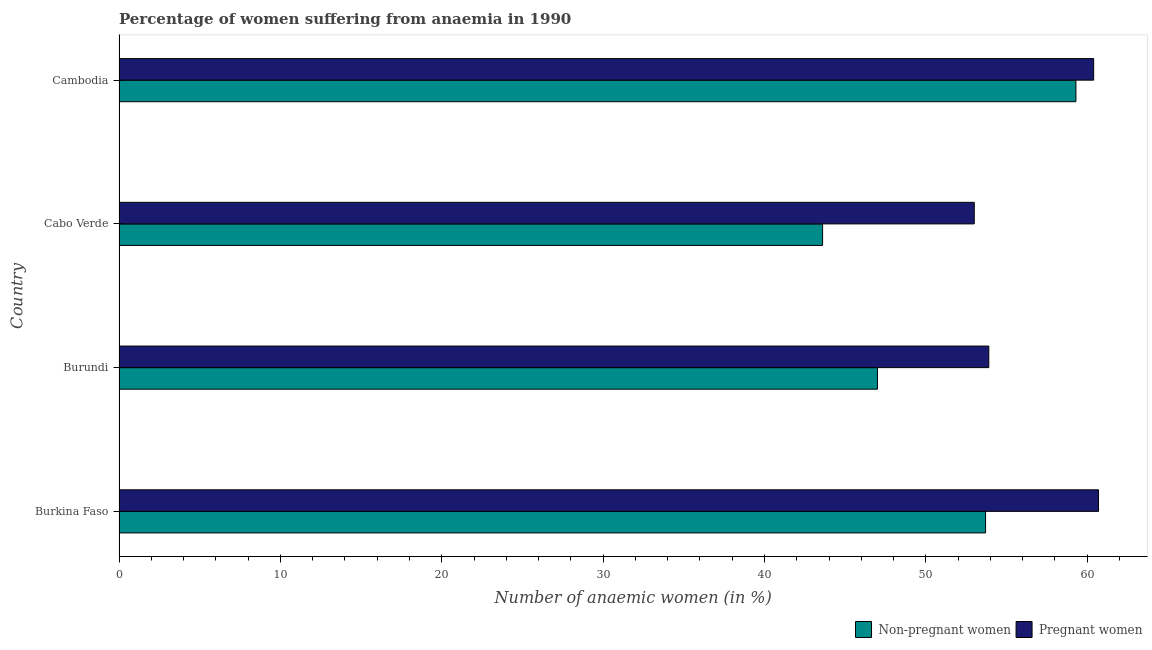How many different coloured bars are there?
Offer a very short reply. 2. How many groups of bars are there?
Keep it short and to the point. 4. Are the number of bars per tick equal to the number of legend labels?
Ensure brevity in your answer.  Yes. What is the label of the 3rd group of bars from the top?
Offer a very short reply. Burundi. What is the percentage of pregnant anaemic women in Burundi?
Offer a very short reply. 53.9. Across all countries, what is the maximum percentage of non-pregnant anaemic women?
Provide a succinct answer. 59.3. Across all countries, what is the minimum percentage of non-pregnant anaemic women?
Offer a terse response. 43.6. In which country was the percentage of non-pregnant anaemic women maximum?
Your response must be concise. Cambodia. In which country was the percentage of non-pregnant anaemic women minimum?
Make the answer very short. Cabo Verde. What is the total percentage of pregnant anaemic women in the graph?
Keep it short and to the point. 228. What is the difference between the percentage of non-pregnant anaemic women in Cabo Verde and that in Cambodia?
Keep it short and to the point. -15.7. What is the difference between the percentage of non-pregnant anaemic women in Cambodia and the percentage of pregnant anaemic women in Cabo Verde?
Your answer should be very brief. 6.3. What is the average percentage of non-pregnant anaemic women per country?
Make the answer very short. 50.9. What is the ratio of the percentage of non-pregnant anaemic women in Burkina Faso to that in Cambodia?
Give a very brief answer. 0.91. In how many countries, is the percentage of pregnant anaemic women greater than the average percentage of pregnant anaemic women taken over all countries?
Keep it short and to the point. 2. Is the sum of the percentage of non-pregnant anaemic women in Burkina Faso and Cambodia greater than the maximum percentage of pregnant anaemic women across all countries?
Your answer should be very brief. Yes. What does the 1st bar from the top in Burkina Faso represents?
Provide a succinct answer. Pregnant women. What does the 2nd bar from the bottom in Cambodia represents?
Give a very brief answer. Pregnant women. Does the graph contain any zero values?
Your response must be concise. No. Does the graph contain grids?
Provide a succinct answer. No. How many legend labels are there?
Provide a short and direct response. 2. How are the legend labels stacked?
Offer a very short reply. Horizontal. What is the title of the graph?
Make the answer very short. Percentage of women suffering from anaemia in 1990. Does "Register a business" appear as one of the legend labels in the graph?
Keep it short and to the point. No. What is the label or title of the X-axis?
Your response must be concise. Number of anaemic women (in %). What is the Number of anaemic women (in %) in Non-pregnant women in Burkina Faso?
Provide a short and direct response. 53.7. What is the Number of anaemic women (in %) of Pregnant women in Burkina Faso?
Your answer should be compact. 60.7. What is the Number of anaemic women (in %) of Pregnant women in Burundi?
Keep it short and to the point. 53.9. What is the Number of anaemic women (in %) of Non-pregnant women in Cabo Verde?
Make the answer very short. 43.6. What is the Number of anaemic women (in %) of Pregnant women in Cabo Verde?
Ensure brevity in your answer.  53. What is the Number of anaemic women (in %) in Non-pregnant women in Cambodia?
Keep it short and to the point. 59.3. What is the Number of anaemic women (in %) in Pregnant women in Cambodia?
Offer a terse response. 60.4. Across all countries, what is the maximum Number of anaemic women (in %) of Non-pregnant women?
Your answer should be compact. 59.3. Across all countries, what is the maximum Number of anaemic women (in %) in Pregnant women?
Provide a succinct answer. 60.7. Across all countries, what is the minimum Number of anaemic women (in %) in Non-pregnant women?
Ensure brevity in your answer.  43.6. Across all countries, what is the minimum Number of anaemic women (in %) of Pregnant women?
Give a very brief answer. 53. What is the total Number of anaemic women (in %) of Non-pregnant women in the graph?
Provide a short and direct response. 203.6. What is the total Number of anaemic women (in %) of Pregnant women in the graph?
Ensure brevity in your answer.  228. What is the difference between the Number of anaemic women (in %) in Non-pregnant women in Burkina Faso and that in Burundi?
Your answer should be compact. 6.7. What is the difference between the Number of anaemic women (in %) of Non-pregnant women in Burkina Faso and that in Cabo Verde?
Offer a very short reply. 10.1. What is the difference between the Number of anaemic women (in %) in Pregnant women in Burkina Faso and that in Cabo Verde?
Your answer should be compact. 7.7. What is the difference between the Number of anaemic women (in %) of Non-pregnant women in Burundi and that in Cambodia?
Your response must be concise. -12.3. What is the difference between the Number of anaemic women (in %) in Non-pregnant women in Cabo Verde and that in Cambodia?
Offer a very short reply. -15.7. What is the difference between the Number of anaemic women (in %) of Pregnant women in Cabo Verde and that in Cambodia?
Your answer should be very brief. -7.4. What is the difference between the Number of anaemic women (in %) of Non-pregnant women in Burkina Faso and the Number of anaemic women (in %) of Pregnant women in Burundi?
Your answer should be compact. -0.2. What is the difference between the Number of anaemic women (in %) in Non-pregnant women in Burkina Faso and the Number of anaemic women (in %) in Pregnant women in Cabo Verde?
Your answer should be compact. 0.7. What is the difference between the Number of anaemic women (in %) in Non-pregnant women in Burkina Faso and the Number of anaemic women (in %) in Pregnant women in Cambodia?
Your answer should be very brief. -6.7. What is the difference between the Number of anaemic women (in %) of Non-pregnant women in Burundi and the Number of anaemic women (in %) of Pregnant women in Cambodia?
Your response must be concise. -13.4. What is the difference between the Number of anaemic women (in %) of Non-pregnant women in Cabo Verde and the Number of anaemic women (in %) of Pregnant women in Cambodia?
Make the answer very short. -16.8. What is the average Number of anaemic women (in %) in Non-pregnant women per country?
Your answer should be very brief. 50.9. What is the average Number of anaemic women (in %) in Pregnant women per country?
Your response must be concise. 57. What is the difference between the Number of anaemic women (in %) of Non-pregnant women and Number of anaemic women (in %) of Pregnant women in Burkina Faso?
Provide a short and direct response. -7. What is the difference between the Number of anaemic women (in %) of Non-pregnant women and Number of anaemic women (in %) of Pregnant women in Cabo Verde?
Your answer should be very brief. -9.4. What is the difference between the Number of anaemic women (in %) of Non-pregnant women and Number of anaemic women (in %) of Pregnant women in Cambodia?
Your response must be concise. -1.1. What is the ratio of the Number of anaemic women (in %) of Non-pregnant women in Burkina Faso to that in Burundi?
Keep it short and to the point. 1.14. What is the ratio of the Number of anaemic women (in %) of Pregnant women in Burkina Faso to that in Burundi?
Make the answer very short. 1.13. What is the ratio of the Number of anaemic women (in %) of Non-pregnant women in Burkina Faso to that in Cabo Verde?
Make the answer very short. 1.23. What is the ratio of the Number of anaemic women (in %) of Pregnant women in Burkina Faso to that in Cabo Verde?
Your response must be concise. 1.15. What is the ratio of the Number of anaemic women (in %) of Non-pregnant women in Burkina Faso to that in Cambodia?
Ensure brevity in your answer.  0.91. What is the ratio of the Number of anaemic women (in %) of Non-pregnant women in Burundi to that in Cabo Verde?
Ensure brevity in your answer.  1.08. What is the ratio of the Number of anaemic women (in %) in Pregnant women in Burundi to that in Cabo Verde?
Your answer should be compact. 1.02. What is the ratio of the Number of anaemic women (in %) of Non-pregnant women in Burundi to that in Cambodia?
Your response must be concise. 0.79. What is the ratio of the Number of anaemic women (in %) in Pregnant women in Burundi to that in Cambodia?
Ensure brevity in your answer.  0.89. What is the ratio of the Number of anaemic women (in %) in Non-pregnant women in Cabo Verde to that in Cambodia?
Your answer should be compact. 0.74. What is the ratio of the Number of anaemic women (in %) in Pregnant women in Cabo Verde to that in Cambodia?
Provide a succinct answer. 0.88. What is the difference between the highest and the second highest Number of anaemic women (in %) in Non-pregnant women?
Your response must be concise. 5.6. What is the difference between the highest and the lowest Number of anaemic women (in %) in Non-pregnant women?
Your answer should be compact. 15.7. What is the difference between the highest and the lowest Number of anaemic women (in %) of Pregnant women?
Keep it short and to the point. 7.7. 